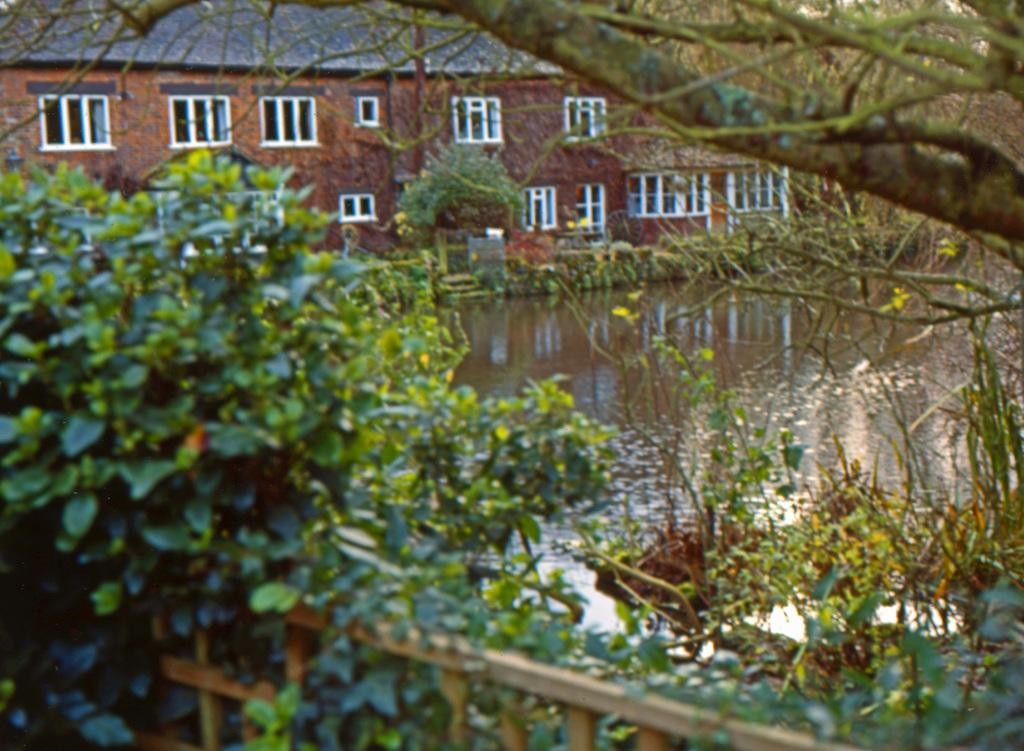What type of vegetation can be seen in the image? There is a tree, plants, and grass visible in the image. What type of structure is present in the image? There is a fence in the image. What natural element is visible in the image? There is water visible in the image. What can be seen in the background of the image? There is a building, windows, and another tree visible in the background of the image. Can you see a ring on any of the trees in the image? There is no ring visible on any of the trees in the image. Is anyone wearing a mask in the image? There is no one wearing a mask in the image. Is there a whip visible in the image? There is no whip visible in the image. 